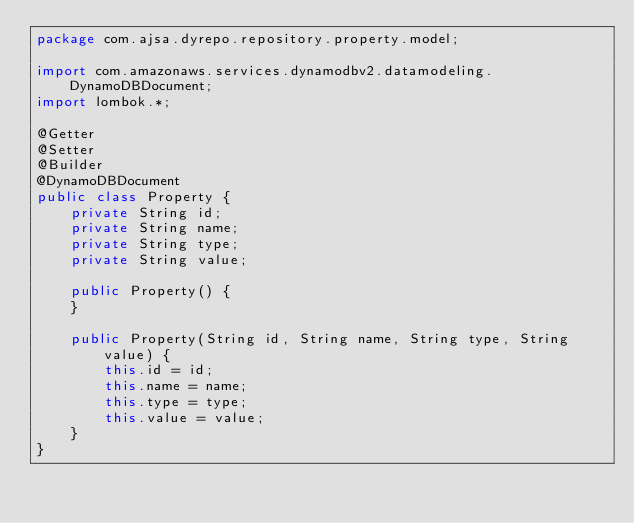Convert code to text. <code><loc_0><loc_0><loc_500><loc_500><_Java_>package com.ajsa.dyrepo.repository.property.model;

import com.amazonaws.services.dynamodbv2.datamodeling.DynamoDBDocument;
import lombok.*;

@Getter
@Setter
@Builder
@DynamoDBDocument
public class Property {
    private String id;
    private String name;
    private String type;
    private String value;

    public Property() {
    }

    public Property(String id, String name, String type, String value) {
        this.id = id;
        this.name = name;
        this.type = type;
        this.value = value;
    }
}
</code> 